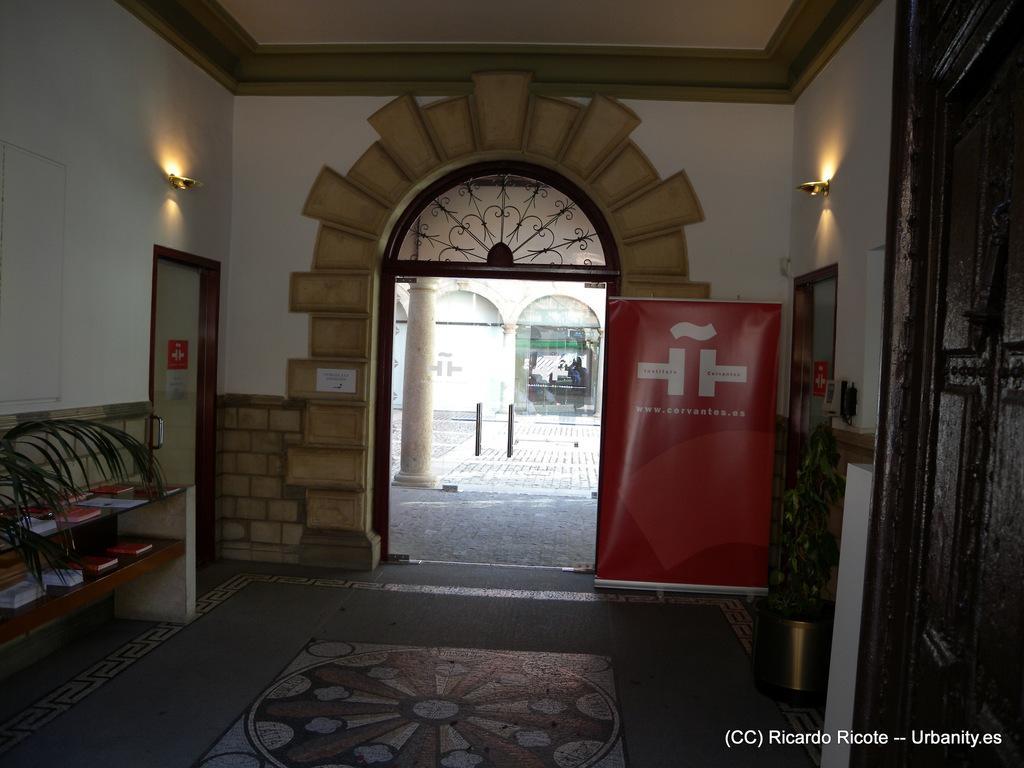Could you give a brief overview of what you see in this image? There is a hall, in which, there are books arranged in shelves, near a plant. On the left side, there is a light which is attached to the white wall, near a door. On the right side, there is a red color banner, near a light which is attached to the wall and a pot plant. In the background, there is a pillar, there are poles and there is a white color building which is having glass door. 